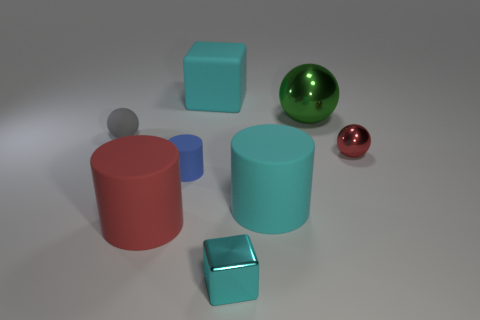Add 1 small cyan shiny cubes. How many objects exist? 9 Subtract all small cylinders. How many cylinders are left? 2 Subtract 1 balls. How many balls are left? 2 Subtract all cyan cylinders. How many cylinders are left? 2 Add 6 gray spheres. How many gray spheres are left? 7 Add 8 big red things. How many big red things exist? 9 Subtract 0 purple balls. How many objects are left? 8 Subtract all cubes. How many objects are left? 6 Subtract all gray cubes. Subtract all yellow cylinders. How many cubes are left? 2 Subtract all brown cubes. How many green balls are left? 1 